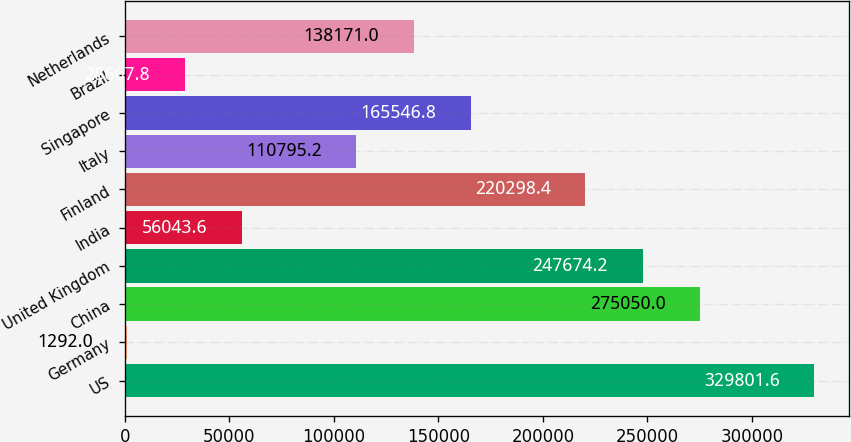<chart> <loc_0><loc_0><loc_500><loc_500><bar_chart><fcel>US<fcel>Germany<fcel>China<fcel>United Kingdom<fcel>India<fcel>Finland<fcel>Italy<fcel>Singapore<fcel>Brazil<fcel>Netherlands<nl><fcel>329802<fcel>1292<fcel>275050<fcel>247674<fcel>56043.6<fcel>220298<fcel>110795<fcel>165547<fcel>28667.8<fcel>138171<nl></chart> 